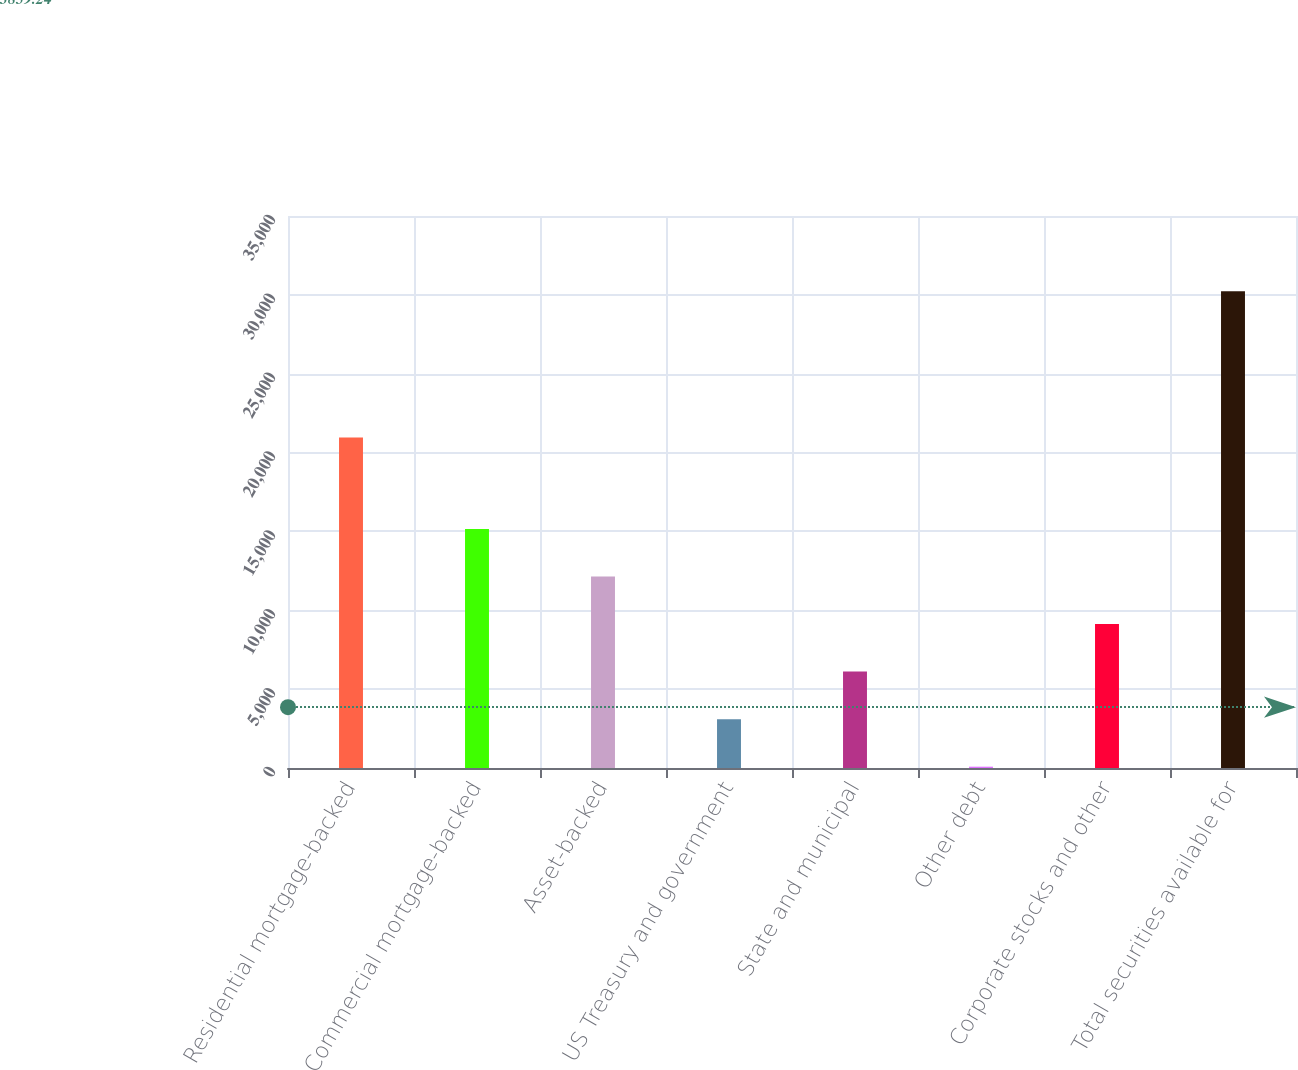Convert chart. <chart><loc_0><loc_0><loc_500><loc_500><bar_chart><fcel>Residential mortgage-backed<fcel>Commercial mortgage-backed<fcel>Asset-backed<fcel>US Treasury and government<fcel>State and municipal<fcel>Other debt<fcel>Corporate stocks and other<fcel>Total securities available for<nl><fcel>20952<fcel>15154.5<fcel>12140.4<fcel>3098.1<fcel>6112.2<fcel>84<fcel>9126.3<fcel>30225<nl></chart> 